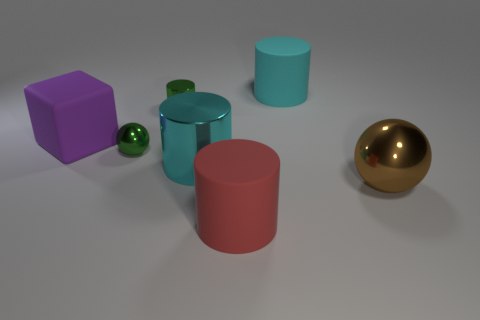Subtract 0 red blocks. How many objects are left? 7 Subtract all cubes. How many objects are left? 6 Subtract 3 cylinders. How many cylinders are left? 1 Subtract all yellow blocks. Subtract all green cylinders. How many blocks are left? 1 Subtract all cyan cylinders. How many cyan blocks are left? 0 Subtract all big rubber cylinders. Subtract all big cyan metal cylinders. How many objects are left? 4 Add 5 big purple matte cubes. How many big purple matte cubes are left? 6 Add 3 large gray rubber things. How many large gray rubber things exist? 3 Add 1 big blue cylinders. How many objects exist? 8 Subtract all red cylinders. How many cylinders are left? 3 